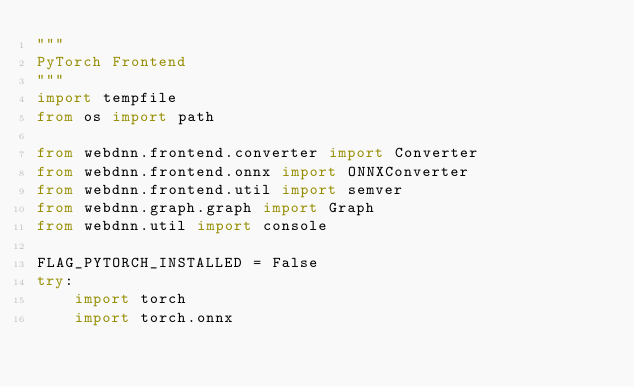<code> <loc_0><loc_0><loc_500><loc_500><_Python_>"""
PyTorch Frontend
"""
import tempfile
from os import path

from webdnn.frontend.converter import Converter
from webdnn.frontend.onnx import ONNXConverter
from webdnn.frontend.util import semver
from webdnn.graph.graph import Graph
from webdnn.util import console

FLAG_PYTORCH_INSTALLED = False
try:
    import torch
    import torch.onnx
</code> 